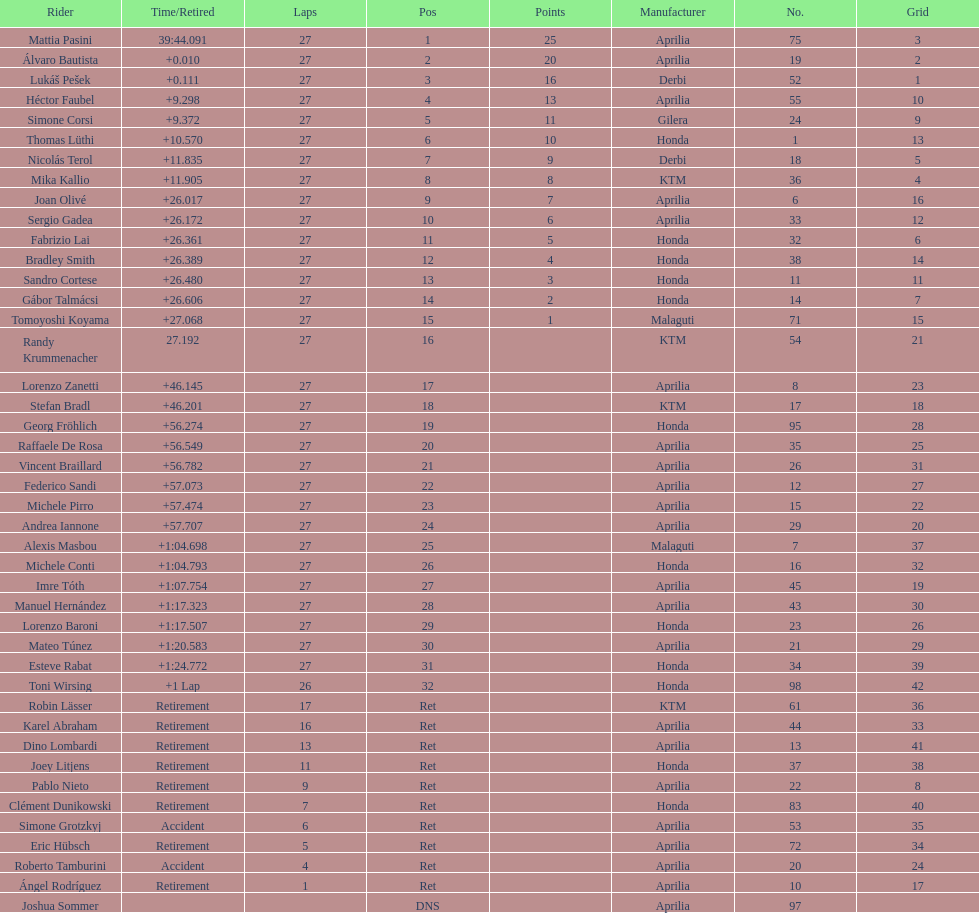Out of all the people who have points, who has the least? Tomoyoshi Koyama. 